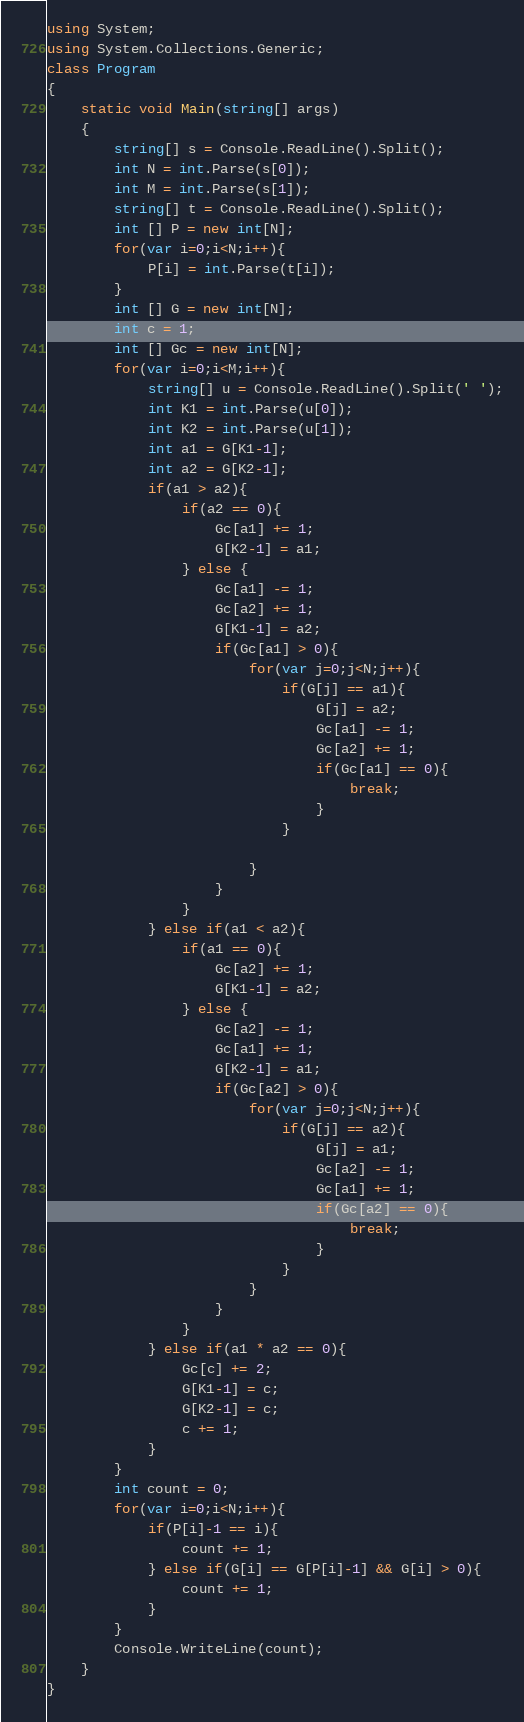Convert code to text. <code><loc_0><loc_0><loc_500><loc_500><_C#_>using System;
using System.Collections.Generic;
class Program
{
	static void Main(string[] args)
	{
		string[] s = Console.ReadLine().Split();
		int N = int.Parse(s[0]);
		int M = int.Parse(s[1]);
		string[] t = Console.ReadLine().Split();
		int [] P = new int[N];
		for(var i=0;i<N;i++){
			P[i] = int.Parse(t[i]);
		}
		int [] G = new int[N];
		int c = 1;
		int [] Gc = new int[N];
		for(var i=0;i<M;i++){
			string[] u = Console.ReadLine().Split(' ');
			int K1 = int.Parse(u[0]);
			int K2 = int.Parse(u[1]);
			int a1 = G[K1-1];
			int a2 = G[K2-1];
			if(a1 > a2){
				if(a2 == 0){
					Gc[a1] += 1;
					G[K2-1] = a1;
				} else {
					Gc[a1] -= 1;
					Gc[a2] += 1;
					G[K1-1] = a2;
					if(Gc[a1] > 0){
						for(var j=0;j<N;j++){
							if(G[j] == a1){
								G[j] = a2;
								Gc[a1] -= 1;
								Gc[a2] += 1;
								if(Gc[a1] == 0){
									break;
								}
							}
							
						}
					}
				}
			} else if(a1 < a2){
				if(a1 == 0){
					Gc[a2] += 1;
					G[K1-1] = a2;
				} else {
					Gc[a2] -= 1;
					Gc[a1] += 1;
					G[K2-1] = a1;
					if(Gc[a2] > 0){
						for(var j=0;j<N;j++){
							if(G[j] == a2){
								G[j] = a1;
								Gc[a2] -= 1;
								Gc[a1] += 1;
								if(Gc[a2] == 0){
									break;
								}
							}
						}
					}
				}
			} else if(a1 * a2 == 0){
				Gc[c] += 2;
				G[K1-1] = c;
				G[K2-1] = c;
				c += 1;
			}
		}
		int count = 0;
		for(var i=0;i<N;i++){
			if(P[i]-1 == i){
				count += 1;
			} else if(G[i] == G[P[i]-1] && G[i] > 0){
				count += 1;
			}
		}
		Console.WriteLine(count);
	}
}</code> 